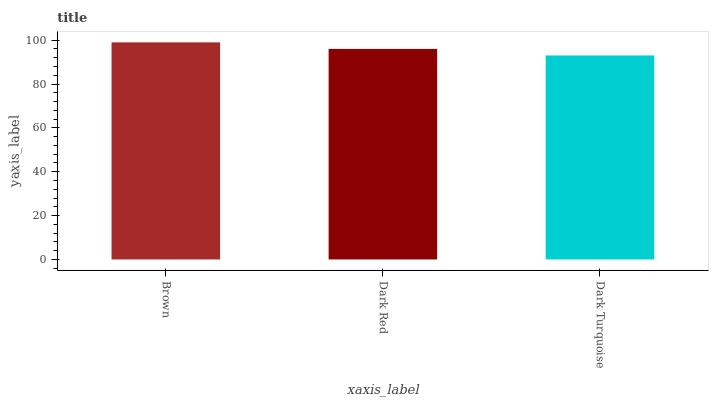Is Dark Turquoise the minimum?
Answer yes or no. Yes. Is Brown the maximum?
Answer yes or no. Yes. Is Dark Red the minimum?
Answer yes or no. No. Is Dark Red the maximum?
Answer yes or no. No. Is Brown greater than Dark Red?
Answer yes or no. Yes. Is Dark Red less than Brown?
Answer yes or no. Yes. Is Dark Red greater than Brown?
Answer yes or no. No. Is Brown less than Dark Red?
Answer yes or no. No. Is Dark Red the high median?
Answer yes or no. Yes. Is Dark Red the low median?
Answer yes or no. Yes. Is Brown the high median?
Answer yes or no. No. Is Dark Turquoise the low median?
Answer yes or no. No. 